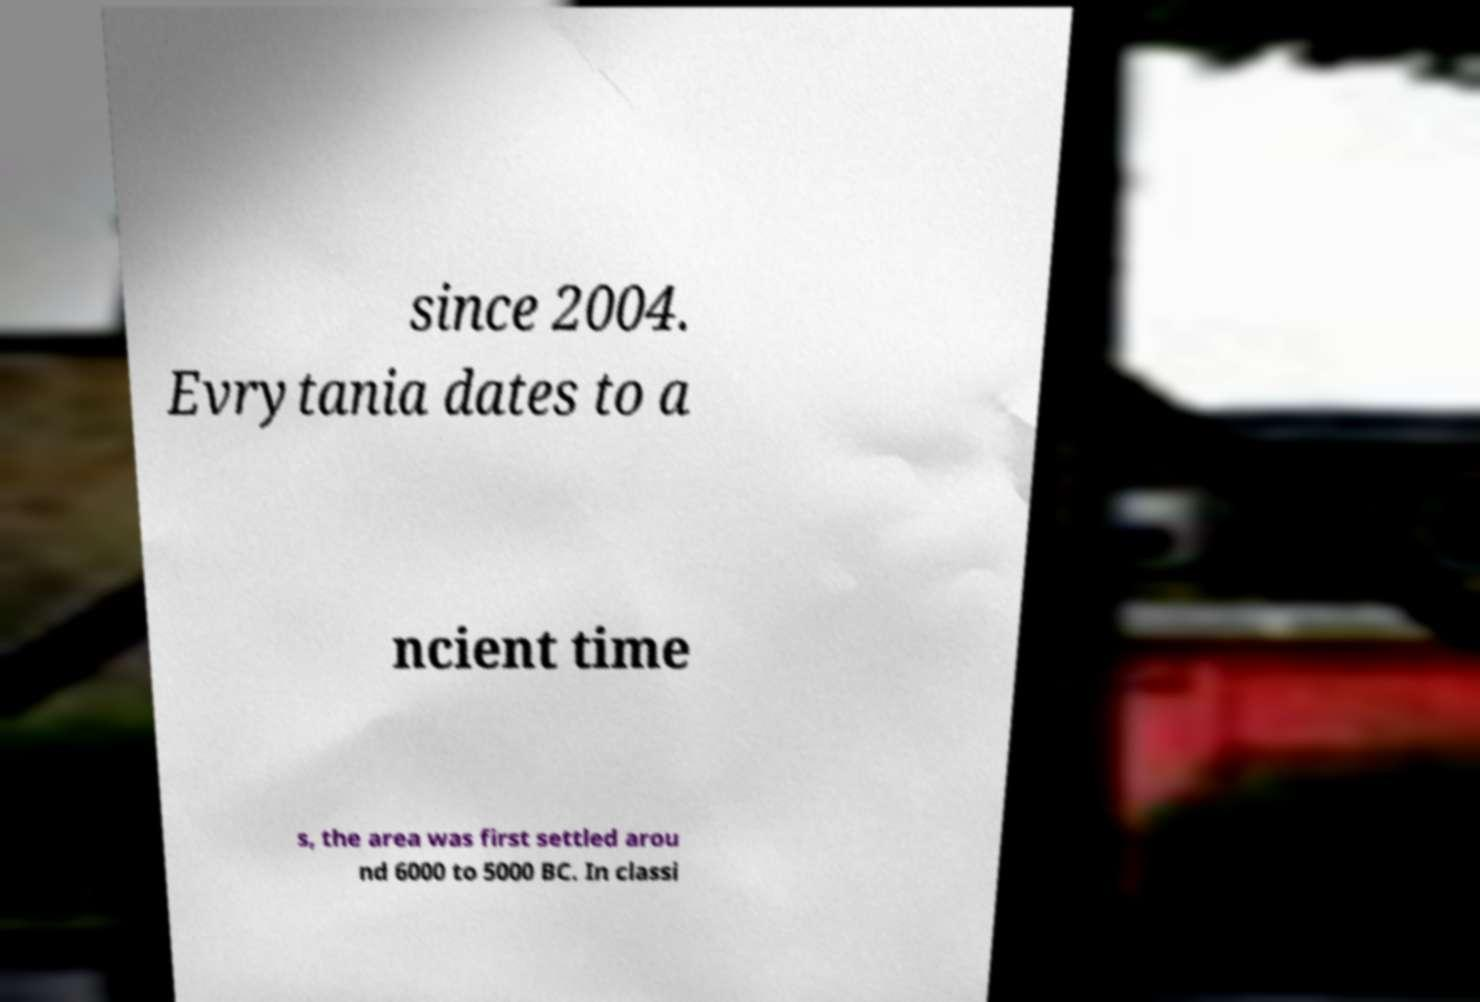Can you read and provide the text displayed in the image?This photo seems to have some interesting text. Can you extract and type it out for me? since 2004. Evrytania dates to a ncient time s, the area was first settled arou nd 6000 to 5000 BC. In classi 